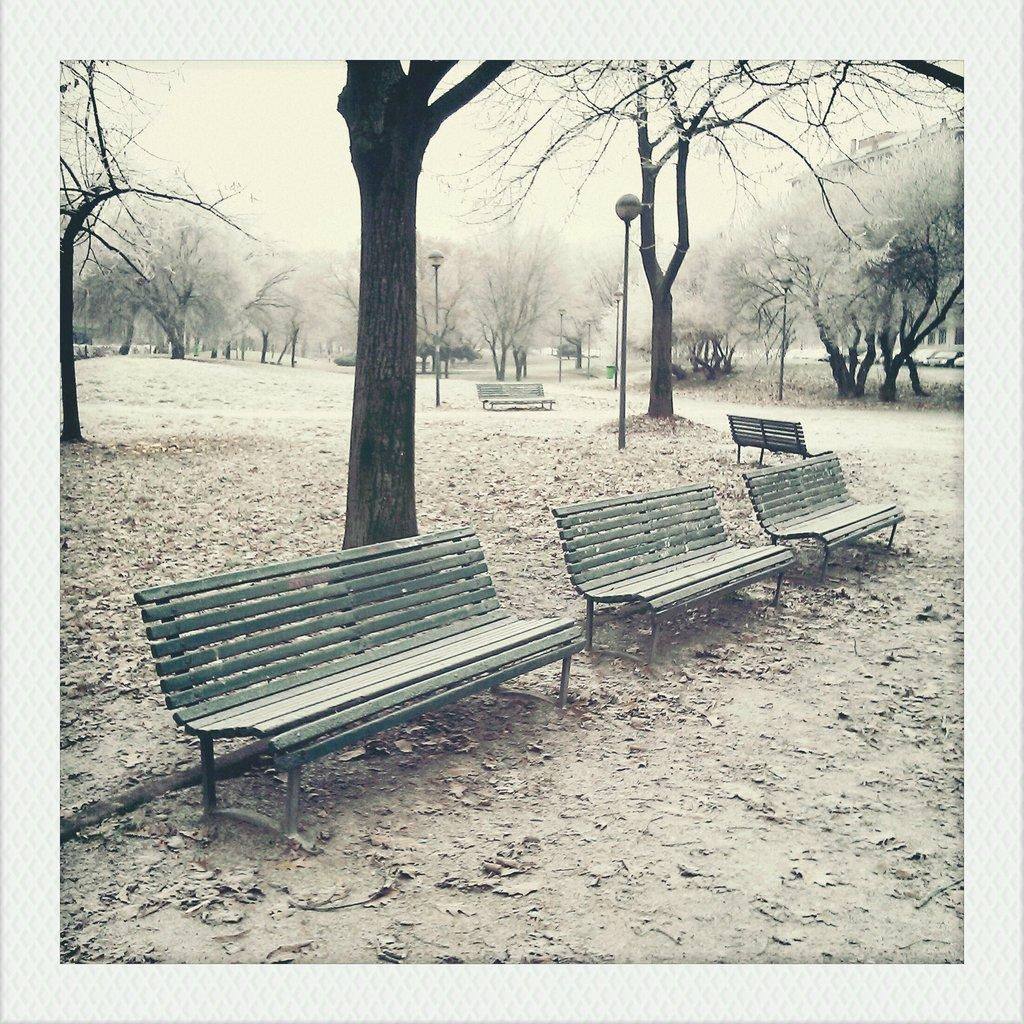What objects are located in the center of the image? There are benches in the center of the image. What can be seen in the background of the image? There are trees in the background of the image. What is the weight of the sidewalk in the image? There is no sidewalk present in the image, so it is not possible to determine its weight. 